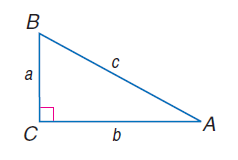Answer the mathemtical geometry problem and directly provide the correct option letter.
Question: a = 14, b = 48, and c = 50, find \sin B.
Choices: A: 0.04 B: 0.48 C: 0.50 D: 0.96 D 